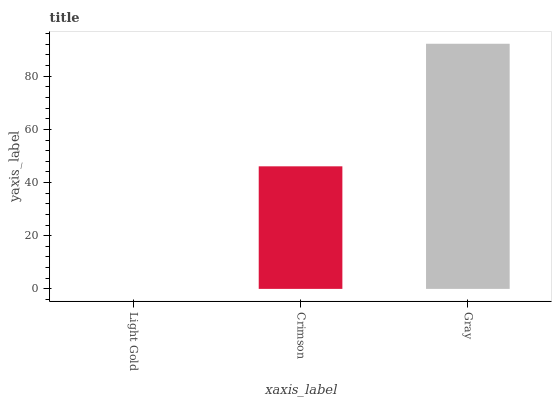Is Crimson the minimum?
Answer yes or no. No. Is Crimson the maximum?
Answer yes or no. No. Is Crimson greater than Light Gold?
Answer yes or no. Yes. Is Light Gold less than Crimson?
Answer yes or no. Yes. Is Light Gold greater than Crimson?
Answer yes or no. No. Is Crimson less than Light Gold?
Answer yes or no. No. Is Crimson the high median?
Answer yes or no. Yes. Is Crimson the low median?
Answer yes or no. Yes. Is Light Gold the high median?
Answer yes or no. No. Is Gray the low median?
Answer yes or no. No. 